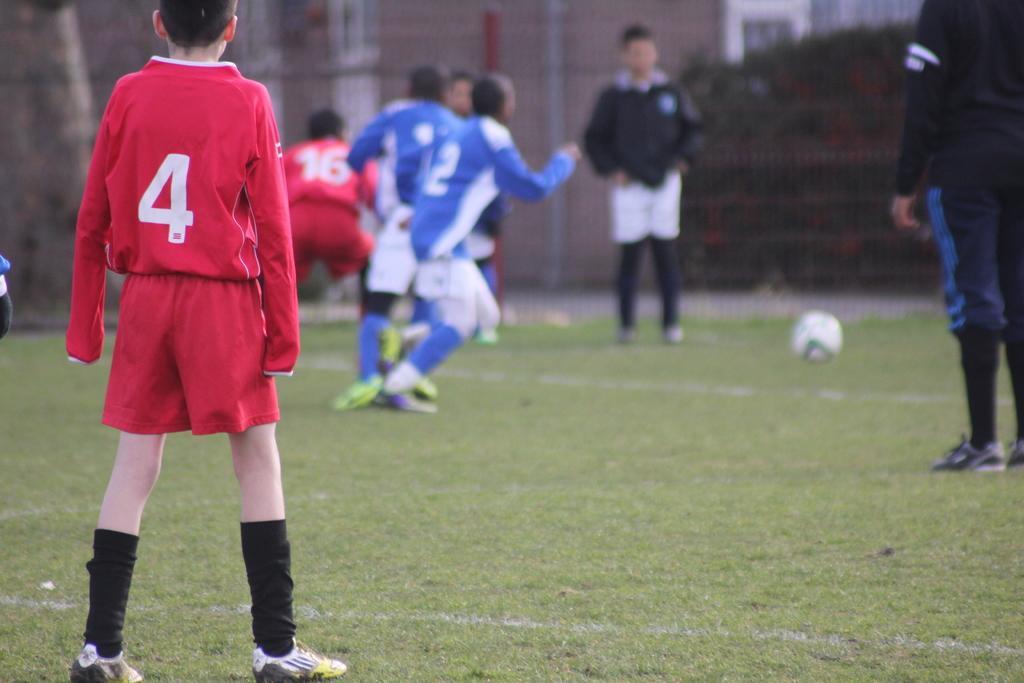Describe this image in one or two sentences. In this image we can see some group of persons wearing red and blue color dress respectively playing foot ball and there are some persons wearing black color dress also standing and in the background of the image there are some trees. 